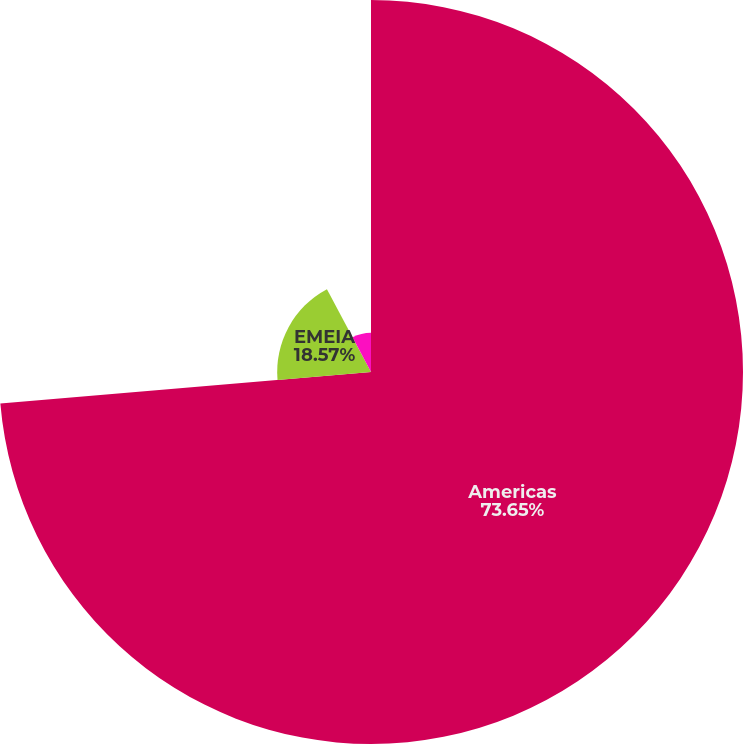<chart> <loc_0><loc_0><loc_500><loc_500><pie_chart><fcel>Americas<fcel>EMEIA<fcel>Asia Pacific<nl><fcel>73.64%<fcel>18.57%<fcel>7.78%<nl></chart> 